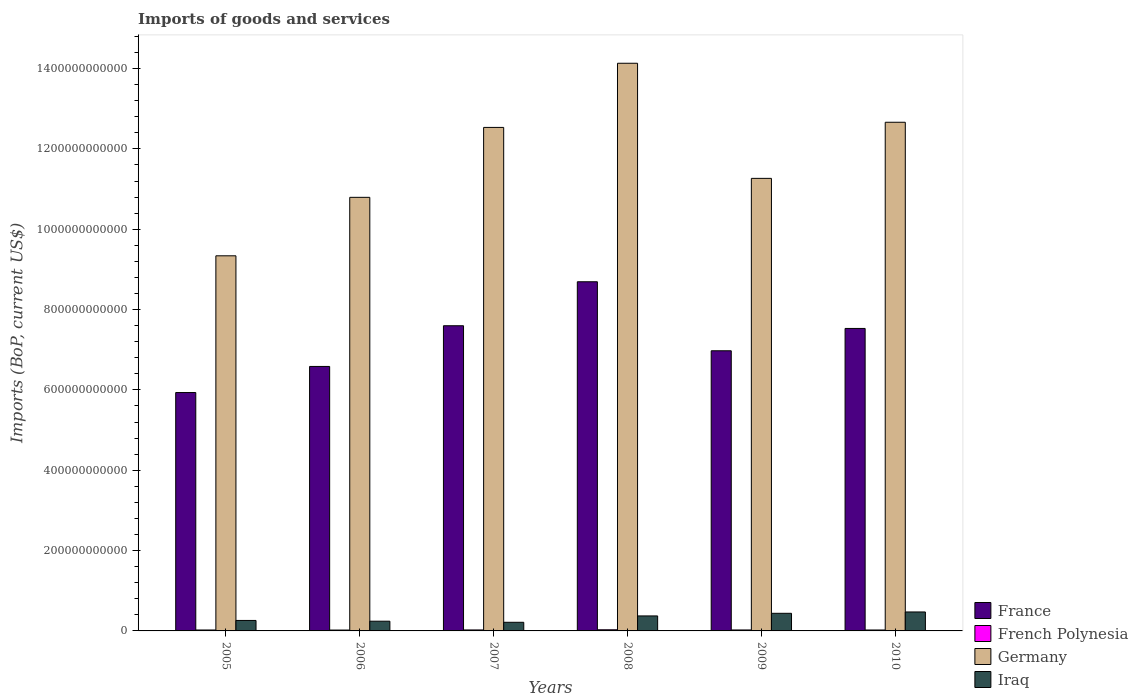How many different coloured bars are there?
Your response must be concise. 4. How many groups of bars are there?
Keep it short and to the point. 6. How many bars are there on the 1st tick from the left?
Give a very brief answer. 4. What is the label of the 4th group of bars from the left?
Make the answer very short. 2008. What is the amount spent on imports in France in 2009?
Offer a terse response. 6.97e+11. Across all years, what is the maximum amount spent on imports in Germany?
Provide a succinct answer. 1.41e+12. Across all years, what is the minimum amount spent on imports in Germany?
Your response must be concise. 9.34e+11. What is the total amount spent on imports in Germany in the graph?
Give a very brief answer. 7.07e+12. What is the difference between the amount spent on imports in France in 2007 and that in 2008?
Offer a terse response. -1.09e+11. What is the difference between the amount spent on imports in France in 2010 and the amount spent on imports in French Polynesia in 2005?
Make the answer very short. 7.51e+11. What is the average amount spent on imports in Germany per year?
Provide a short and direct response. 1.18e+12. In the year 2006, what is the difference between the amount spent on imports in Iraq and amount spent on imports in France?
Ensure brevity in your answer.  -6.34e+11. What is the ratio of the amount spent on imports in Iraq in 2008 to that in 2009?
Make the answer very short. 0.85. What is the difference between the highest and the second highest amount spent on imports in French Polynesia?
Provide a short and direct response. 4.33e+08. What is the difference between the highest and the lowest amount spent on imports in Iraq?
Provide a succinct answer. 2.57e+1. Is the sum of the amount spent on imports in French Polynesia in 2005 and 2008 greater than the maximum amount spent on imports in France across all years?
Make the answer very short. No. Is it the case that in every year, the sum of the amount spent on imports in Iraq and amount spent on imports in France is greater than the sum of amount spent on imports in French Polynesia and amount spent on imports in Germany?
Offer a terse response. No. What does the 3rd bar from the left in 2005 represents?
Offer a terse response. Germany. How many bars are there?
Ensure brevity in your answer.  24. What is the difference between two consecutive major ticks on the Y-axis?
Offer a very short reply. 2.00e+11. Are the values on the major ticks of Y-axis written in scientific E-notation?
Provide a short and direct response. No. Does the graph contain grids?
Provide a short and direct response. No. What is the title of the graph?
Give a very brief answer. Imports of goods and services. What is the label or title of the X-axis?
Keep it short and to the point. Years. What is the label or title of the Y-axis?
Offer a very short reply. Imports (BoP, current US$). What is the Imports (BoP, current US$) of France in 2005?
Your response must be concise. 5.93e+11. What is the Imports (BoP, current US$) of French Polynesia in 2005?
Give a very brief answer. 2.31e+09. What is the Imports (BoP, current US$) in Germany in 2005?
Give a very brief answer. 9.34e+11. What is the Imports (BoP, current US$) of Iraq in 2005?
Provide a short and direct response. 2.61e+1. What is the Imports (BoP, current US$) in France in 2006?
Give a very brief answer. 6.58e+11. What is the Imports (BoP, current US$) in French Polynesia in 2006?
Provide a short and direct response. 2.16e+09. What is the Imports (BoP, current US$) in Germany in 2006?
Your answer should be very brief. 1.08e+12. What is the Imports (BoP, current US$) in Iraq in 2006?
Your answer should be compact. 2.42e+1. What is the Imports (BoP, current US$) in France in 2007?
Your response must be concise. 7.60e+11. What is the Imports (BoP, current US$) in French Polynesia in 2007?
Keep it short and to the point. 2.43e+09. What is the Imports (BoP, current US$) in Germany in 2007?
Your response must be concise. 1.25e+12. What is the Imports (BoP, current US$) of Iraq in 2007?
Ensure brevity in your answer.  2.15e+1. What is the Imports (BoP, current US$) of France in 2008?
Provide a succinct answer. 8.69e+11. What is the Imports (BoP, current US$) of French Polynesia in 2008?
Your answer should be compact. 2.87e+09. What is the Imports (BoP, current US$) of Germany in 2008?
Give a very brief answer. 1.41e+12. What is the Imports (BoP, current US$) in Iraq in 2008?
Your answer should be compact. 3.73e+1. What is the Imports (BoP, current US$) in France in 2009?
Ensure brevity in your answer.  6.97e+11. What is the Imports (BoP, current US$) of French Polynesia in 2009?
Offer a terse response. 2.38e+09. What is the Imports (BoP, current US$) of Germany in 2009?
Offer a very short reply. 1.13e+12. What is the Imports (BoP, current US$) in Iraq in 2009?
Your answer should be compact. 4.38e+1. What is the Imports (BoP, current US$) of France in 2010?
Your answer should be very brief. 7.53e+11. What is the Imports (BoP, current US$) of French Polynesia in 2010?
Give a very brief answer. 2.33e+09. What is the Imports (BoP, current US$) in Germany in 2010?
Give a very brief answer. 1.27e+12. What is the Imports (BoP, current US$) in Iraq in 2010?
Provide a succinct answer. 4.72e+1. Across all years, what is the maximum Imports (BoP, current US$) in France?
Offer a very short reply. 8.69e+11. Across all years, what is the maximum Imports (BoP, current US$) of French Polynesia?
Your response must be concise. 2.87e+09. Across all years, what is the maximum Imports (BoP, current US$) in Germany?
Provide a short and direct response. 1.41e+12. Across all years, what is the maximum Imports (BoP, current US$) of Iraq?
Offer a very short reply. 4.72e+1. Across all years, what is the minimum Imports (BoP, current US$) of France?
Your answer should be very brief. 5.93e+11. Across all years, what is the minimum Imports (BoP, current US$) of French Polynesia?
Offer a very short reply. 2.16e+09. Across all years, what is the minimum Imports (BoP, current US$) in Germany?
Give a very brief answer. 9.34e+11. Across all years, what is the minimum Imports (BoP, current US$) of Iraq?
Make the answer very short. 2.15e+1. What is the total Imports (BoP, current US$) in France in the graph?
Provide a succinct answer. 4.33e+12. What is the total Imports (BoP, current US$) in French Polynesia in the graph?
Offer a terse response. 1.45e+1. What is the total Imports (BoP, current US$) in Germany in the graph?
Offer a terse response. 7.07e+12. What is the total Imports (BoP, current US$) of Iraq in the graph?
Your answer should be very brief. 2.00e+11. What is the difference between the Imports (BoP, current US$) of France in 2005 and that in 2006?
Offer a very short reply. -6.50e+1. What is the difference between the Imports (BoP, current US$) of French Polynesia in 2005 and that in 2006?
Keep it short and to the point. 1.59e+08. What is the difference between the Imports (BoP, current US$) of Germany in 2005 and that in 2006?
Keep it short and to the point. -1.46e+11. What is the difference between the Imports (BoP, current US$) of Iraq in 2005 and that in 2006?
Provide a short and direct response. 1.90e+09. What is the difference between the Imports (BoP, current US$) in France in 2005 and that in 2007?
Your response must be concise. -1.66e+11. What is the difference between the Imports (BoP, current US$) in French Polynesia in 2005 and that in 2007?
Give a very brief answer. -1.17e+08. What is the difference between the Imports (BoP, current US$) in Germany in 2005 and that in 2007?
Make the answer very short. -3.20e+11. What is the difference between the Imports (BoP, current US$) in Iraq in 2005 and that in 2007?
Keep it short and to the point. 4.61e+09. What is the difference between the Imports (BoP, current US$) in France in 2005 and that in 2008?
Your response must be concise. -2.76e+11. What is the difference between the Imports (BoP, current US$) in French Polynesia in 2005 and that in 2008?
Keep it short and to the point. -5.50e+08. What is the difference between the Imports (BoP, current US$) in Germany in 2005 and that in 2008?
Your answer should be very brief. -4.79e+11. What is the difference between the Imports (BoP, current US$) in Iraq in 2005 and that in 2008?
Provide a succinct answer. -1.12e+1. What is the difference between the Imports (BoP, current US$) in France in 2005 and that in 2009?
Offer a terse response. -1.04e+11. What is the difference between the Imports (BoP, current US$) in French Polynesia in 2005 and that in 2009?
Ensure brevity in your answer.  -6.25e+07. What is the difference between the Imports (BoP, current US$) of Germany in 2005 and that in 2009?
Your answer should be very brief. -1.93e+11. What is the difference between the Imports (BoP, current US$) in Iraq in 2005 and that in 2009?
Provide a succinct answer. -1.78e+1. What is the difference between the Imports (BoP, current US$) in France in 2005 and that in 2010?
Your response must be concise. -1.60e+11. What is the difference between the Imports (BoP, current US$) in French Polynesia in 2005 and that in 2010?
Provide a short and direct response. -1.53e+07. What is the difference between the Imports (BoP, current US$) of Germany in 2005 and that in 2010?
Keep it short and to the point. -3.32e+11. What is the difference between the Imports (BoP, current US$) of Iraq in 2005 and that in 2010?
Provide a short and direct response. -2.11e+1. What is the difference between the Imports (BoP, current US$) in France in 2006 and that in 2007?
Offer a very short reply. -1.01e+11. What is the difference between the Imports (BoP, current US$) in French Polynesia in 2006 and that in 2007?
Ensure brevity in your answer.  -2.76e+08. What is the difference between the Imports (BoP, current US$) in Germany in 2006 and that in 2007?
Provide a succinct answer. -1.74e+11. What is the difference between the Imports (BoP, current US$) of Iraq in 2006 and that in 2007?
Give a very brief answer. 2.71e+09. What is the difference between the Imports (BoP, current US$) in France in 2006 and that in 2008?
Provide a succinct answer. -2.11e+11. What is the difference between the Imports (BoP, current US$) of French Polynesia in 2006 and that in 2008?
Provide a short and direct response. -7.10e+08. What is the difference between the Imports (BoP, current US$) in Germany in 2006 and that in 2008?
Provide a succinct answer. -3.34e+11. What is the difference between the Imports (BoP, current US$) in Iraq in 2006 and that in 2008?
Keep it short and to the point. -1.31e+1. What is the difference between the Imports (BoP, current US$) of France in 2006 and that in 2009?
Offer a terse response. -3.90e+1. What is the difference between the Imports (BoP, current US$) of French Polynesia in 2006 and that in 2009?
Provide a short and direct response. -2.22e+08. What is the difference between the Imports (BoP, current US$) in Germany in 2006 and that in 2009?
Give a very brief answer. -4.72e+1. What is the difference between the Imports (BoP, current US$) in Iraq in 2006 and that in 2009?
Give a very brief answer. -1.97e+1. What is the difference between the Imports (BoP, current US$) in France in 2006 and that in 2010?
Offer a very short reply. -9.46e+1. What is the difference between the Imports (BoP, current US$) of French Polynesia in 2006 and that in 2010?
Your answer should be very brief. -1.75e+08. What is the difference between the Imports (BoP, current US$) of Germany in 2006 and that in 2010?
Provide a short and direct response. -1.87e+11. What is the difference between the Imports (BoP, current US$) in Iraq in 2006 and that in 2010?
Keep it short and to the point. -2.30e+1. What is the difference between the Imports (BoP, current US$) in France in 2007 and that in 2008?
Your answer should be compact. -1.09e+11. What is the difference between the Imports (BoP, current US$) in French Polynesia in 2007 and that in 2008?
Ensure brevity in your answer.  -4.33e+08. What is the difference between the Imports (BoP, current US$) of Germany in 2007 and that in 2008?
Ensure brevity in your answer.  -1.60e+11. What is the difference between the Imports (BoP, current US$) of Iraq in 2007 and that in 2008?
Your answer should be very brief. -1.58e+1. What is the difference between the Imports (BoP, current US$) in France in 2007 and that in 2009?
Keep it short and to the point. 6.23e+1. What is the difference between the Imports (BoP, current US$) of French Polynesia in 2007 and that in 2009?
Keep it short and to the point. 5.44e+07. What is the difference between the Imports (BoP, current US$) of Germany in 2007 and that in 2009?
Offer a terse response. 1.27e+11. What is the difference between the Imports (BoP, current US$) of Iraq in 2007 and that in 2009?
Your answer should be very brief. -2.24e+1. What is the difference between the Imports (BoP, current US$) in France in 2007 and that in 2010?
Your response must be concise. 6.70e+09. What is the difference between the Imports (BoP, current US$) in French Polynesia in 2007 and that in 2010?
Your answer should be compact. 1.02e+08. What is the difference between the Imports (BoP, current US$) of Germany in 2007 and that in 2010?
Offer a terse response. -1.28e+1. What is the difference between the Imports (BoP, current US$) of Iraq in 2007 and that in 2010?
Offer a terse response. -2.57e+1. What is the difference between the Imports (BoP, current US$) of France in 2008 and that in 2009?
Your answer should be compact. 1.72e+11. What is the difference between the Imports (BoP, current US$) of French Polynesia in 2008 and that in 2009?
Give a very brief answer. 4.88e+08. What is the difference between the Imports (BoP, current US$) in Germany in 2008 and that in 2009?
Ensure brevity in your answer.  2.87e+11. What is the difference between the Imports (BoP, current US$) in Iraq in 2008 and that in 2009?
Provide a short and direct response. -6.51e+09. What is the difference between the Imports (BoP, current US$) of France in 2008 and that in 2010?
Offer a terse response. 1.16e+11. What is the difference between the Imports (BoP, current US$) in French Polynesia in 2008 and that in 2010?
Your response must be concise. 5.35e+08. What is the difference between the Imports (BoP, current US$) of Germany in 2008 and that in 2010?
Provide a short and direct response. 1.47e+11. What is the difference between the Imports (BoP, current US$) of Iraq in 2008 and that in 2010?
Your answer should be compact. -9.86e+09. What is the difference between the Imports (BoP, current US$) in France in 2009 and that in 2010?
Your response must be concise. -5.56e+1. What is the difference between the Imports (BoP, current US$) in French Polynesia in 2009 and that in 2010?
Your answer should be compact. 4.72e+07. What is the difference between the Imports (BoP, current US$) of Germany in 2009 and that in 2010?
Your answer should be very brief. -1.40e+11. What is the difference between the Imports (BoP, current US$) in Iraq in 2009 and that in 2010?
Give a very brief answer. -3.34e+09. What is the difference between the Imports (BoP, current US$) of France in 2005 and the Imports (BoP, current US$) of French Polynesia in 2006?
Your response must be concise. 5.91e+11. What is the difference between the Imports (BoP, current US$) in France in 2005 and the Imports (BoP, current US$) in Germany in 2006?
Ensure brevity in your answer.  -4.86e+11. What is the difference between the Imports (BoP, current US$) in France in 2005 and the Imports (BoP, current US$) in Iraq in 2006?
Provide a succinct answer. 5.69e+11. What is the difference between the Imports (BoP, current US$) of French Polynesia in 2005 and the Imports (BoP, current US$) of Germany in 2006?
Make the answer very short. -1.08e+12. What is the difference between the Imports (BoP, current US$) in French Polynesia in 2005 and the Imports (BoP, current US$) in Iraq in 2006?
Ensure brevity in your answer.  -2.19e+1. What is the difference between the Imports (BoP, current US$) in Germany in 2005 and the Imports (BoP, current US$) in Iraq in 2006?
Provide a succinct answer. 9.10e+11. What is the difference between the Imports (BoP, current US$) of France in 2005 and the Imports (BoP, current US$) of French Polynesia in 2007?
Offer a terse response. 5.91e+11. What is the difference between the Imports (BoP, current US$) in France in 2005 and the Imports (BoP, current US$) in Germany in 2007?
Your answer should be very brief. -6.60e+11. What is the difference between the Imports (BoP, current US$) of France in 2005 and the Imports (BoP, current US$) of Iraq in 2007?
Provide a short and direct response. 5.72e+11. What is the difference between the Imports (BoP, current US$) in French Polynesia in 2005 and the Imports (BoP, current US$) in Germany in 2007?
Your answer should be very brief. -1.25e+12. What is the difference between the Imports (BoP, current US$) in French Polynesia in 2005 and the Imports (BoP, current US$) in Iraq in 2007?
Provide a short and direct response. -1.92e+1. What is the difference between the Imports (BoP, current US$) of Germany in 2005 and the Imports (BoP, current US$) of Iraq in 2007?
Ensure brevity in your answer.  9.12e+11. What is the difference between the Imports (BoP, current US$) of France in 2005 and the Imports (BoP, current US$) of French Polynesia in 2008?
Offer a terse response. 5.91e+11. What is the difference between the Imports (BoP, current US$) in France in 2005 and the Imports (BoP, current US$) in Germany in 2008?
Give a very brief answer. -8.20e+11. What is the difference between the Imports (BoP, current US$) in France in 2005 and the Imports (BoP, current US$) in Iraq in 2008?
Keep it short and to the point. 5.56e+11. What is the difference between the Imports (BoP, current US$) in French Polynesia in 2005 and the Imports (BoP, current US$) in Germany in 2008?
Offer a very short reply. -1.41e+12. What is the difference between the Imports (BoP, current US$) of French Polynesia in 2005 and the Imports (BoP, current US$) of Iraq in 2008?
Provide a succinct answer. -3.50e+1. What is the difference between the Imports (BoP, current US$) of Germany in 2005 and the Imports (BoP, current US$) of Iraq in 2008?
Offer a very short reply. 8.97e+11. What is the difference between the Imports (BoP, current US$) of France in 2005 and the Imports (BoP, current US$) of French Polynesia in 2009?
Offer a terse response. 5.91e+11. What is the difference between the Imports (BoP, current US$) in France in 2005 and the Imports (BoP, current US$) in Germany in 2009?
Provide a succinct answer. -5.33e+11. What is the difference between the Imports (BoP, current US$) of France in 2005 and the Imports (BoP, current US$) of Iraq in 2009?
Offer a very short reply. 5.50e+11. What is the difference between the Imports (BoP, current US$) of French Polynesia in 2005 and the Imports (BoP, current US$) of Germany in 2009?
Offer a very short reply. -1.12e+12. What is the difference between the Imports (BoP, current US$) of French Polynesia in 2005 and the Imports (BoP, current US$) of Iraq in 2009?
Your answer should be compact. -4.15e+1. What is the difference between the Imports (BoP, current US$) of Germany in 2005 and the Imports (BoP, current US$) of Iraq in 2009?
Offer a very short reply. 8.90e+11. What is the difference between the Imports (BoP, current US$) of France in 2005 and the Imports (BoP, current US$) of French Polynesia in 2010?
Give a very brief answer. 5.91e+11. What is the difference between the Imports (BoP, current US$) of France in 2005 and the Imports (BoP, current US$) of Germany in 2010?
Your answer should be very brief. -6.73e+11. What is the difference between the Imports (BoP, current US$) of France in 2005 and the Imports (BoP, current US$) of Iraq in 2010?
Keep it short and to the point. 5.46e+11. What is the difference between the Imports (BoP, current US$) of French Polynesia in 2005 and the Imports (BoP, current US$) of Germany in 2010?
Your answer should be compact. -1.26e+12. What is the difference between the Imports (BoP, current US$) of French Polynesia in 2005 and the Imports (BoP, current US$) of Iraq in 2010?
Your response must be concise. -4.49e+1. What is the difference between the Imports (BoP, current US$) in Germany in 2005 and the Imports (BoP, current US$) in Iraq in 2010?
Keep it short and to the point. 8.87e+11. What is the difference between the Imports (BoP, current US$) of France in 2006 and the Imports (BoP, current US$) of French Polynesia in 2007?
Give a very brief answer. 6.56e+11. What is the difference between the Imports (BoP, current US$) in France in 2006 and the Imports (BoP, current US$) in Germany in 2007?
Provide a short and direct response. -5.95e+11. What is the difference between the Imports (BoP, current US$) in France in 2006 and the Imports (BoP, current US$) in Iraq in 2007?
Make the answer very short. 6.37e+11. What is the difference between the Imports (BoP, current US$) of French Polynesia in 2006 and the Imports (BoP, current US$) of Germany in 2007?
Provide a short and direct response. -1.25e+12. What is the difference between the Imports (BoP, current US$) in French Polynesia in 2006 and the Imports (BoP, current US$) in Iraq in 2007?
Your response must be concise. -1.93e+1. What is the difference between the Imports (BoP, current US$) in Germany in 2006 and the Imports (BoP, current US$) in Iraq in 2007?
Your response must be concise. 1.06e+12. What is the difference between the Imports (BoP, current US$) in France in 2006 and the Imports (BoP, current US$) in French Polynesia in 2008?
Your response must be concise. 6.56e+11. What is the difference between the Imports (BoP, current US$) of France in 2006 and the Imports (BoP, current US$) of Germany in 2008?
Your answer should be very brief. -7.55e+11. What is the difference between the Imports (BoP, current US$) in France in 2006 and the Imports (BoP, current US$) in Iraq in 2008?
Provide a succinct answer. 6.21e+11. What is the difference between the Imports (BoP, current US$) in French Polynesia in 2006 and the Imports (BoP, current US$) in Germany in 2008?
Your answer should be very brief. -1.41e+12. What is the difference between the Imports (BoP, current US$) in French Polynesia in 2006 and the Imports (BoP, current US$) in Iraq in 2008?
Your answer should be very brief. -3.52e+1. What is the difference between the Imports (BoP, current US$) of Germany in 2006 and the Imports (BoP, current US$) of Iraq in 2008?
Keep it short and to the point. 1.04e+12. What is the difference between the Imports (BoP, current US$) in France in 2006 and the Imports (BoP, current US$) in French Polynesia in 2009?
Provide a succinct answer. 6.56e+11. What is the difference between the Imports (BoP, current US$) in France in 2006 and the Imports (BoP, current US$) in Germany in 2009?
Your response must be concise. -4.68e+11. What is the difference between the Imports (BoP, current US$) of France in 2006 and the Imports (BoP, current US$) of Iraq in 2009?
Make the answer very short. 6.15e+11. What is the difference between the Imports (BoP, current US$) in French Polynesia in 2006 and the Imports (BoP, current US$) in Germany in 2009?
Your response must be concise. -1.12e+12. What is the difference between the Imports (BoP, current US$) in French Polynesia in 2006 and the Imports (BoP, current US$) in Iraq in 2009?
Make the answer very short. -4.17e+1. What is the difference between the Imports (BoP, current US$) of Germany in 2006 and the Imports (BoP, current US$) of Iraq in 2009?
Keep it short and to the point. 1.04e+12. What is the difference between the Imports (BoP, current US$) in France in 2006 and the Imports (BoP, current US$) in French Polynesia in 2010?
Your answer should be compact. 6.56e+11. What is the difference between the Imports (BoP, current US$) in France in 2006 and the Imports (BoP, current US$) in Germany in 2010?
Keep it short and to the point. -6.08e+11. What is the difference between the Imports (BoP, current US$) in France in 2006 and the Imports (BoP, current US$) in Iraq in 2010?
Offer a terse response. 6.11e+11. What is the difference between the Imports (BoP, current US$) of French Polynesia in 2006 and the Imports (BoP, current US$) of Germany in 2010?
Make the answer very short. -1.26e+12. What is the difference between the Imports (BoP, current US$) in French Polynesia in 2006 and the Imports (BoP, current US$) in Iraq in 2010?
Your answer should be compact. -4.50e+1. What is the difference between the Imports (BoP, current US$) in Germany in 2006 and the Imports (BoP, current US$) in Iraq in 2010?
Your answer should be very brief. 1.03e+12. What is the difference between the Imports (BoP, current US$) in France in 2007 and the Imports (BoP, current US$) in French Polynesia in 2008?
Make the answer very short. 7.57e+11. What is the difference between the Imports (BoP, current US$) of France in 2007 and the Imports (BoP, current US$) of Germany in 2008?
Your answer should be compact. -6.53e+11. What is the difference between the Imports (BoP, current US$) of France in 2007 and the Imports (BoP, current US$) of Iraq in 2008?
Provide a short and direct response. 7.22e+11. What is the difference between the Imports (BoP, current US$) in French Polynesia in 2007 and the Imports (BoP, current US$) in Germany in 2008?
Provide a succinct answer. -1.41e+12. What is the difference between the Imports (BoP, current US$) in French Polynesia in 2007 and the Imports (BoP, current US$) in Iraq in 2008?
Keep it short and to the point. -3.49e+1. What is the difference between the Imports (BoP, current US$) in Germany in 2007 and the Imports (BoP, current US$) in Iraq in 2008?
Ensure brevity in your answer.  1.22e+12. What is the difference between the Imports (BoP, current US$) in France in 2007 and the Imports (BoP, current US$) in French Polynesia in 2009?
Offer a terse response. 7.57e+11. What is the difference between the Imports (BoP, current US$) of France in 2007 and the Imports (BoP, current US$) of Germany in 2009?
Provide a succinct answer. -3.67e+11. What is the difference between the Imports (BoP, current US$) of France in 2007 and the Imports (BoP, current US$) of Iraq in 2009?
Give a very brief answer. 7.16e+11. What is the difference between the Imports (BoP, current US$) in French Polynesia in 2007 and the Imports (BoP, current US$) in Germany in 2009?
Your answer should be compact. -1.12e+12. What is the difference between the Imports (BoP, current US$) of French Polynesia in 2007 and the Imports (BoP, current US$) of Iraq in 2009?
Provide a short and direct response. -4.14e+1. What is the difference between the Imports (BoP, current US$) of Germany in 2007 and the Imports (BoP, current US$) of Iraq in 2009?
Ensure brevity in your answer.  1.21e+12. What is the difference between the Imports (BoP, current US$) of France in 2007 and the Imports (BoP, current US$) of French Polynesia in 2010?
Your answer should be very brief. 7.57e+11. What is the difference between the Imports (BoP, current US$) of France in 2007 and the Imports (BoP, current US$) of Germany in 2010?
Provide a succinct answer. -5.07e+11. What is the difference between the Imports (BoP, current US$) in France in 2007 and the Imports (BoP, current US$) in Iraq in 2010?
Ensure brevity in your answer.  7.13e+11. What is the difference between the Imports (BoP, current US$) of French Polynesia in 2007 and the Imports (BoP, current US$) of Germany in 2010?
Give a very brief answer. -1.26e+12. What is the difference between the Imports (BoP, current US$) of French Polynesia in 2007 and the Imports (BoP, current US$) of Iraq in 2010?
Offer a very short reply. -4.48e+1. What is the difference between the Imports (BoP, current US$) in Germany in 2007 and the Imports (BoP, current US$) in Iraq in 2010?
Keep it short and to the point. 1.21e+12. What is the difference between the Imports (BoP, current US$) of France in 2008 and the Imports (BoP, current US$) of French Polynesia in 2009?
Ensure brevity in your answer.  8.67e+11. What is the difference between the Imports (BoP, current US$) in France in 2008 and the Imports (BoP, current US$) in Germany in 2009?
Offer a very short reply. -2.57e+11. What is the difference between the Imports (BoP, current US$) in France in 2008 and the Imports (BoP, current US$) in Iraq in 2009?
Offer a very short reply. 8.25e+11. What is the difference between the Imports (BoP, current US$) of French Polynesia in 2008 and the Imports (BoP, current US$) of Germany in 2009?
Give a very brief answer. -1.12e+12. What is the difference between the Imports (BoP, current US$) of French Polynesia in 2008 and the Imports (BoP, current US$) of Iraq in 2009?
Provide a short and direct response. -4.10e+1. What is the difference between the Imports (BoP, current US$) of Germany in 2008 and the Imports (BoP, current US$) of Iraq in 2009?
Give a very brief answer. 1.37e+12. What is the difference between the Imports (BoP, current US$) of France in 2008 and the Imports (BoP, current US$) of French Polynesia in 2010?
Keep it short and to the point. 8.67e+11. What is the difference between the Imports (BoP, current US$) of France in 2008 and the Imports (BoP, current US$) of Germany in 2010?
Your answer should be compact. -3.97e+11. What is the difference between the Imports (BoP, current US$) in France in 2008 and the Imports (BoP, current US$) in Iraq in 2010?
Make the answer very short. 8.22e+11. What is the difference between the Imports (BoP, current US$) in French Polynesia in 2008 and the Imports (BoP, current US$) in Germany in 2010?
Provide a succinct answer. -1.26e+12. What is the difference between the Imports (BoP, current US$) of French Polynesia in 2008 and the Imports (BoP, current US$) of Iraq in 2010?
Your answer should be very brief. -4.43e+1. What is the difference between the Imports (BoP, current US$) of Germany in 2008 and the Imports (BoP, current US$) of Iraq in 2010?
Your response must be concise. 1.37e+12. What is the difference between the Imports (BoP, current US$) of France in 2009 and the Imports (BoP, current US$) of French Polynesia in 2010?
Offer a very short reply. 6.95e+11. What is the difference between the Imports (BoP, current US$) of France in 2009 and the Imports (BoP, current US$) of Germany in 2010?
Make the answer very short. -5.69e+11. What is the difference between the Imports (BoP, current US$) in France in 2009 and the Imports (BoP, current US$) in Iraq in 2010?
Ensure brevity in your answer.  6.50e+11. What is the difference between the Imports (BoP, current US$) in French Polynesia in 2009 and the Imports (BoP, current US$) in Germany in 2010?
Provide a short and direct response. -1.26e+12. What is the difference between the Imports (BoP, current US$) of French Polynesia in 2009 and the Imports (BoP, current US$) of Iraq in 2010?
Your response must be concise. -4.48e+1. What is the difference between the Imports (BoP, current US$) in Germany in 2009 and the Imports (BoP, current US$) in Iraq in 2010?
Keep it short and to the point. 1.08e+12. What is the average Imports (BoP, current US$) in France per year?
Keep it short and to the point. 7.22e+11. What is the average Imports (BoP, current US$) in French Polynesia per year?
Make the answer very short. 2.41e+09. What is the average Imports (BoP, current US$) in Germany per year?
Offer a very short reply. 1.18e+12. What is the average Imports (BoP, current US$) of Iraq per year?
Your answer should be compact. 3.34e+1. In the year 2005, what is the difference between the Imports (BoP, current US$) in France and Imports (BoP, current US$) in French Polynesia?
Ensure brevity in your answer.  5.91e+11. In the year 2005, what is the difference between the Imports (BoP, current US$) in France and Imports (BoP, current US$) in Germany?
Your answer should be very brief. -3.40e+11. In the year 2005, what is the difference between the Imports (BoP, current US$) of France and Imports (BoP, current US$) of Iraq?
Make the answer very short. 5.67e+11. In the year 2005, what is the difference between the Imports (BoP, current US$) in French Polynesia and Imports (BoP, current US$) in Germany?
Offer a very short reply. -9.32e+11. In the year 2005, what is the difference between the Imports (BoP, current US$) of French Polynesia and Imports (BoP, current US$) of Iraq?
Your answer should be very brief. -2.38e+1. In the year 2005, what is the difference between the Imports (BoP, current US$) in Germany and Imports (BoP, current US$) in Iraq?
Keep it short and to the point. 9.08e+11. In the year 2006, what is the difference between the Imports (BoP, current US$) in France and Imports (BoP, current US$) in French Polynesia?
Your response must be concise. 6.56e+11. In the year 2006, what is the difference between the Imports (BoP, current US$) of France and Imports (BoP, current US$) of Germany?
Your answer should be compact. -4.21e+11. In the year 2006, what is the difference between the Imports (BoP, current US$) of France and Imports (BoP, current US$) of Iraq?
Your answer should be compact. 6.34e+11. In the year 2006, what is the difference between the Imports (BoP, current US$) of French Polynesia and Imports (BoP, current US$) of Germany?
Your answer should be compact. -1.08e+12. In the year 2006, what is the difference between the Imports (BoP, current US$) in French Polynesia and Imports (BoP, current US$) in Iraq?
Make the answer very short. -2.20e+1. In the year 2006, what is the difference between the Imports (BoP, current US$) of Germany and Imports (BoP, current US$) of Iraq?
Offer a terse response. 1.06e+12. In the year 2007, what is the difference between the Imports (BoP, current US$) of France and Imports (BoP, current US$) of French Polynesia?
Your answer should be very brief. 7.57e+11. In the year 2007, what is the difference between the Imports (BoP, current US$) of France and Imports (BoP, current US$) of Germany?
Your response must be concise. -4.94e+11. In the year 2007, what is the difference between the Imports (BoP, current US$) of France and Imports (BoP, current US$) of Iraq?
Give a very brief answer. 7.38e+11. In the year 2007, what is the difference between the Imports (BoP, current US$) of French Polynesia and Imports (BoP, current US$) of Germany?
Your answer should be very brief. -1.25e+12. In the year 2007, what is the difference between the Imports (BoP, current US$) in French Polynesia and Imports (BoP, current US$) in Iraq?
Your answer should be compact. -1.91e+1. In the year 2007, what is the difference between the Imports (BoP, current US$) in Germany and Imports (BoP, current US$) in Iraq?
Provide a short and direct response. 1.23e+12. In the year 2008, what is the difference between the Imports (BoP, current US$) of France and Imports (BoP, current US$) of French Polynesia?
Offer a very short reply. 8.66e+11. In the year 2008, what is the difference between the Imports (BoP, current US$) in France and Imports (BoP, current US$) in Germany?
Give a very brief answer. -5.44e+11. In the year 2008, what is the difference between the Imports (BoP, current US$) in France and Imports (BoP, current US$) in Iraq?
Give a very brief answer. 8.32e+11. In the year 2008, what is the difference between the Imports (BoP, current US$) of French Polynesia and Imports (BoP, current US$) of Germany?
Offer a terse response. -1.41e+12. In the year 2008, what is the difference between the Imports (BoP, current US$) of French Polynesia and Imports (BoP, current US$) of Iraq?
Keep it short and to the point. -3.45e+1. In the year 2008, what is the difference between the Imports (BoP, current US$) of Germany and Imports (BoP, current US$) of Iraq?
Keep it short and to the point. 1.38e+12. In the year 2009, what is the difference between the Imports (BoP, current US$) in France and Imports (BoP, current US$) in French Polynesia?
Make the answer very short. 6.95e+11. In the year 2009, what is the difference between the Imports (BoP, current US$) in France and Imports (BoP, current US$) in Germany?
Provide a succinct answer. -4.29e+11. In the year 2009, what is the difference between the Imports (BoP, current US$) of France and Imports (BoP, current US$) of Iraq?
Your answer should be compact. 6.54e+11. In the year 2009, what is the difference between the Imports (BoP, current US$) in French Polynesia and Imports (BoP, current US$) in Germany?
Offer a very short reply. -1.12e+12. In the year 2009, what is the difference between the Imports (BoP, current US$) of French Polynesia and Imports (BoP, current US$) of Iraq?
Offer a very short reply. -4.15e+1. In the year 2009, what is the difference between the Imports (BoP, current US$) in Germany and Imports (BoP, current US$) in Iraq?
Your response must be concise. 1.08e+12. In the year 2010, what is the difference between the Imports (BoP, current US$) in France and Imports (BoP, current US$) in French Polynesia?
Offer a terse response. 7.51e+11. In the year 2010, what is the difference between the Imports (BoP, current US$) of France and Imports (BoP, current US$) of Germany?
Ensure brevity in your answer.  -5.13e+11. In the year 2010, what is the difference between the Imports (BoP, current US$) of France and Imports (BoP, current US$) of Iraq?
Make the answer very short. 7.06e+11. In the year 2010, what is the difference between the Imports (BoP, current US$) in French Polynesia and Imports (BoP, current US$) in Germany?
Give a very brief answer. -1.26e+12. In the year 2010, what is the difference between the Imports (BoP, current US$) in French Polynesia and Imports (BoP, current US$) in Iraq?
Your response must be concise. -4.49e+1. In the year 2010, what is the difference between the Imports (BoP, current US$) in Germany and Imports (BoP, current US$) in Iraq?
Your answer should be compact. 1.22e+12. What is the ratio of the Imports (BoP, current US$) in France in 2005 to that in 2006?
Your answer should be very brief. 0.9. What is the ratio of the Imports (BoP, current US$) of French Polynesia in 2005 to that in 2006?
Ensure brevity in your answer.  1.07. What is the ratio of the Imports (BoP, current US$) of Germany in 2005 to that in 2006?
Your answer should be very brief. 0.87. What is the ratio of the Imports (BoP, current US$) of Iraq in 2005 to that in 2006?
Make the answer very short. 1.08. What is the ratio of the Imports (BoP, current US$) in France in 2005 to that in 2007?
Ensure brevity in your answer.  0.78. What is the ratio of the Imports (BoP, current US$) in French Polynesia in 2005 to that in 2007?
Offer a terse response. 0.95. What is the ratio of the Imports (BoP, current US$) in Germany in 2005 to that in 2007?
Your answer should be very brief. 0.74. What is the ratio of the Imports (BoP, current US$) in Iraq in 2005 to that in 2007?
Your answer should be compact. 1.21. What is the ratio of the Imports (BoP, current US$) of France in 2005 to that in 2008?
Offer a terse response. 0.68. What is the ratio of the Imports (BoP, current US$) of French Polynesia in 2005 to that in 2008?
Make the answer very short. 0.81. What is the ratio of the Imports (BoP, current US$) in Germany in 2005 to that in 2008?
Provide a succinct answer. 0.66. What is the ratio of the Imports (BoP, current US$) in Iraq in 2005 to that in 2008?
Offer a terse response. 0.7. What is the ratio of the Imports (BoP, current US$) in France in 2005 to that in 2009?
Provide a short and direct response. 0.85. What is the ratio of the Imports (BoP, current US$) in French Polynesia in 2005 to that in 2009?
Your response must be concise. 0.97. What is the ratio of the Imports (BoP, current US$) in Germany in 2005 to that in 2009?
Keep it short and to the point. 0.83. What is the ratio of the Imports (BoP, current US$) in Iraq in 2005 to that in 2009?
Provide a succinct answer. 0.6. What is the ratio of the Imports (BoP, current US$) of France in 2005 to that in 2010?
Make the answer very short. 0.79. What is the ratio of the Imports (BoP, current US$) of French Polynesia in 2005 to that in 2010?
Give a very brief answer. 0.99. What is the ratio of the Imports (BoP, current US$) of Germany in 2005 to that in 2010?
Offer a very short reply. 0.74. What is the ratio of the Imports (BoP, current US$) of Iraq in 2005 to that in 2010?
Your response must be concise. 0.55. What is the ratio of the Imports (BoP, current US$) of France in 2006 to that in 2007?
Make the answer very short. 0.87. What is the ratio of the Imports (BoP, current US$) in French Polynesia in 2006 to that in 2007?
Your answer should be very brief. 0.89. What is the ratio of the Imports (BoP, current US$) of Germany in 2006 to that in 2007?
Provide a succinct answer. 0.86. What is the ratio of the Imports (BoP, current US$) of Iraq in 2006 to that in 2007?
Your answer should be very brief. 1.13. What is the ratio of the Imports (BoP, current US$) of France in 2006 to that in 2008?
Your answer should be very brief. 0.76. What is the ratio of the Imports (BoP, current US$) of French Polynesia in 2006 to that in 2008?
Provide a short and direct response. 0.75. What is the ratio of the Imports (BoP, current US$) of Germany in 2006 to that in 2008?
Keep it short and to the point. 0.76. What is the ratio of the Imports (BoP, current US$) in Iraq in 2006 to that in 2008?
Keep it short and to the point. 0.65. What is the ratio of the Imports (BoP, current US$) of France in 2006 to that in 2009?
Keep it short and to the point. 0.94. What is the ratio of the Imports (BoP, current US$) of French Polynesia in 2006 to that in 2009?
Make the answer very short. 0.91. What is the ratio of the Imports (BoP, current US$) of Germany in 2006 to that in 2009?
Provide a succinct answer. 0.96. What is the ratio of the Imports (BoP, current US$) of Iraq in 2006 to that in 2009?
Your answer should be compact. 0.55. What is the ratio of the Imports (BoP, current US$) in France in 2006 to that in 2010?
Offer a terse response. 0.87. What is the ratio of the Imports (BoP, current US$) of French Polynesia in 2006 to that in 2010?
Provide a succinct answer. 0.93. What is the ratio of the Imports (BoP, current US$) in Germany in 2006 to that in 2010?
Your answer should be very brief. 0.85. What is the ratio of the Imports (BoP, current US$) in Iraq in 2006 to that in 2010?
Give a very brief answer. 0.51. What is the ratio of the Imports (BoP, current US$) of France in 2007 to that in 2008?
Ensure brevity in your answer.  0.87. What is the ratio of the Imports (BoP, current US$) in French Polynesia in 2007 to that in 2008?
Offer a terse response. 0.85. What is the ratio of the Imports (BoP, current US$) in Germany in 2007 to that in 2008?
Keep it short and to the point. 0.89. What is the ratio of the Imports (BoP, current US$) in Iraq in 2007 to that in 2008?
Provide a short and direct response. 0.58. What is the ratio of the Imports (BoP, current US$) of France in 2007 to that in 2009?
Offer a terse response. 1.09. What is the ratio of the Imports (BoP, current US$) of French Polynesia in 2007 to that in 2009?
Make the answer very short. 1.02. What is the ratio of the Imports (BoP, current US$) of Germany in 2007 to that in 2009?
Provide a short and direct response. 1.11. What is the ratio of the Imports (BoP, current US$) in Iraq in 2007 to that in 2009?
Provide a short and direct response. 0.49. What is the ratio of the Imports (BoP, current US$) in France in 2007 to that in 2010?
Keep it short and to the point. 1.01. What is the ratio of the Imports (BoP, current US$) of French Polynesia in 2007 to that in 2010?
Provide a short and direct response. 1.04. What is the ratio of the Imports (BoP, current US$) of Iraq in 2007 to that in 2010?
Make the answer very short. 0.46. What is the ratio of the Imports (BoP, current US$) of France in 2008 to that in 2009?
Your answer should be very brief. 1.25. What is the ratio of the Imports (BoP, current US$) of French Polynesia in 2008 to that in 2009?
Provide a succinct answer. 1.21. What is the ratio of the Imports (BoP, current US$) in Germany in 2008 to that in 2009?
Keep it short and to the point. 1.25. What is the ratio of the Imports (BoP, current US$) in Iraq in 2008 to that in 2009?
Your answer should be very brief. 0.85. What is the ratio of the Imports (BoP, current US$) of France in 2008 to that in 2010?
Make the answer very short. 1.15. What is the ratio of the Imports (BoP, current US$) of French Polynesia in 2008 to that in 2010?
Your answer should be very brief. 1.23. What is the ratio of the Imports (BoP, current US$) of Germany in 2008 to that in 2010?
Provide a succinct answer. 1.12. What is the ratio of the Imports (BoP, current US$) of Iraq in 2008 to that in 2010?
Your answer should be very brief. 0.79. What is the ratio of the Imports (BoP, current US$) in France in 2009 to that in 2010?
Your answer should be very brief. 0.93. What is the ratio of the Imports (BoP, current US$) of French Polynesia in 2009 to that in 2010?
Provide a succinct answer. 1.02. What is the ratio of the Imports (BoP, current US$) in Germany in 2009 to that in 2010?
Offer a very short reply. 0.89. What is the ratio of the Imports (BoP, current US$) in Iraq in 2009 to that in 2010?
Provide a short and direct response. 0.93. What is the difference between the highest and the second highest Imports (BoP, current US$) of France?
Offer a terse response. 1.09e+11. What is the difference between the highest and the second highest Imports (BoP, current US$) in French Polynesia?
Keep it short and to the point. 4.33e+08. What is the difference between the highest and the second highest Imports (BoP, current US$) in Germany?
Provide a short and direct response. 1.47e+11. What is the difference between the highest and the second highest Imports (BoP, current US$) in Iraq?
Offer a terse response. 3.34e+09. What is the difference between the highest and the lowest Imports (BoP, current US$) in France?
Offer a very short reply. 2.76e+11. What is the difference between the highest and the lowest Imports (BoP, current US$) of French Polynesia?
Offer a terse response. 7.10e+08. What is the difference between the highest and the lowest Imports (BoP, current US$) in Germany?
Offer a very short reply. 4.79e+11. What is the difference between the highest and the lowest Imports (BoP, current US$) of Iraq?
Provide a short and direct response. 2.57e+1. 